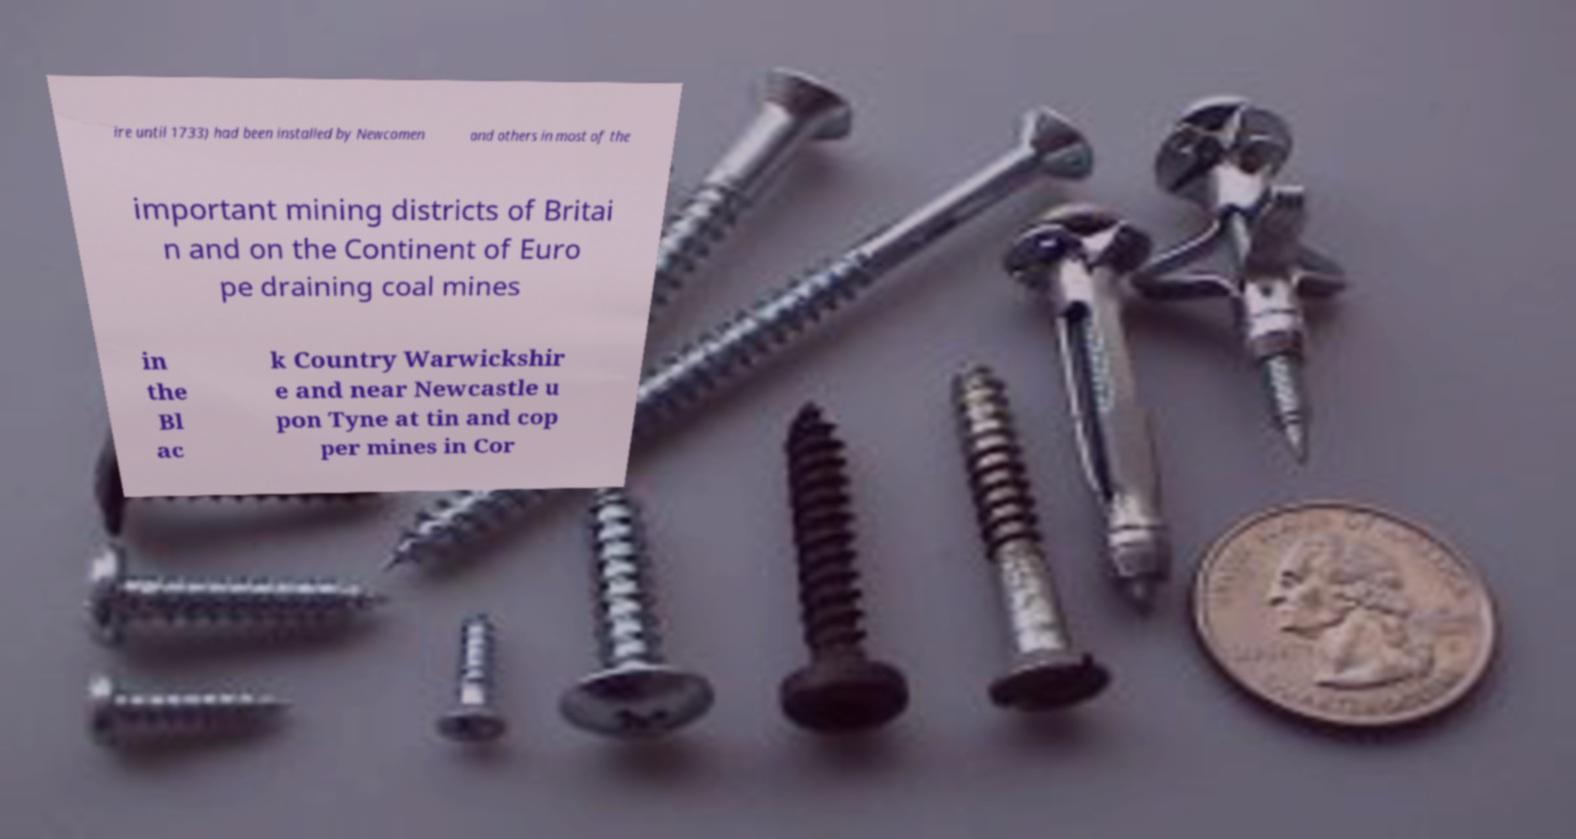I need the written content from this picture converted into text. Can you do that? ire until 1733) had been installed by Newcomen and others in most of the important mining districts of Britai n and on the Continent of Euro pe draining coal mines in the Bl ac k Country Warwickshir e and near Newcastle u pon Tyne at tin and cop per mines in Cor 